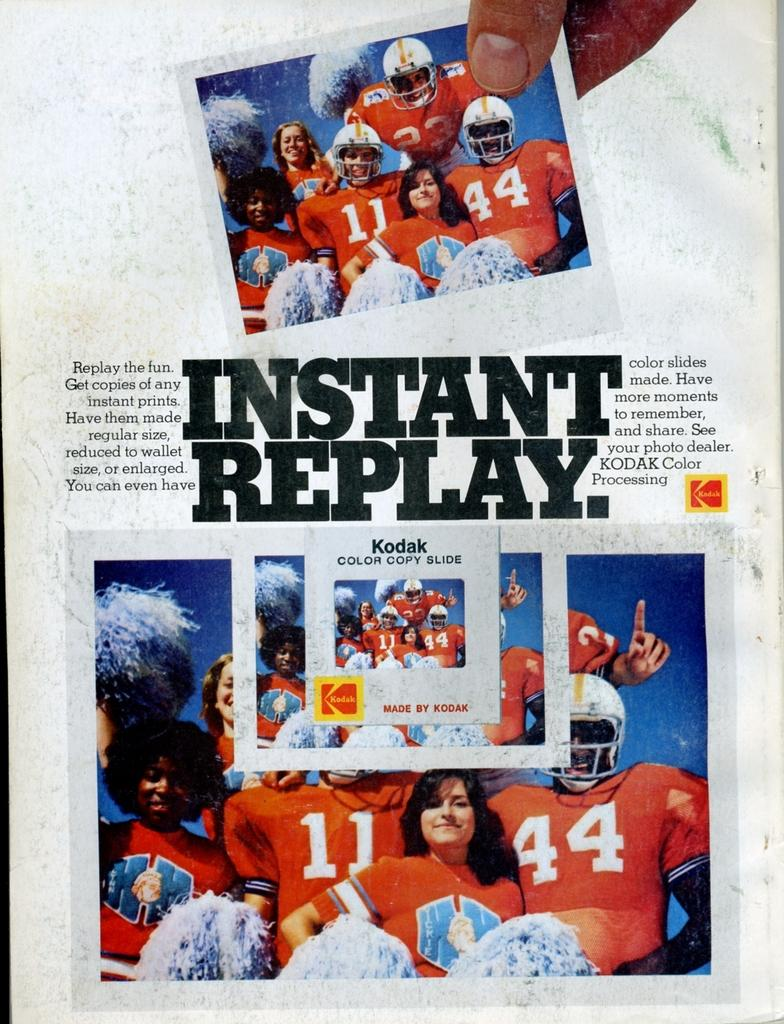What can be found in the image that contains written information? There is text in the image. How many photographs are present in the image? There are two photographs in the image. What do the photographs depict? The photographs contain images of players. What color is the background of the image? The background of the image is white. Can you see a sock in the image? There is no sock present in the image. Is there a plane visible in the photographs? The photographs contain images of players, and there is no plane visible in them. 